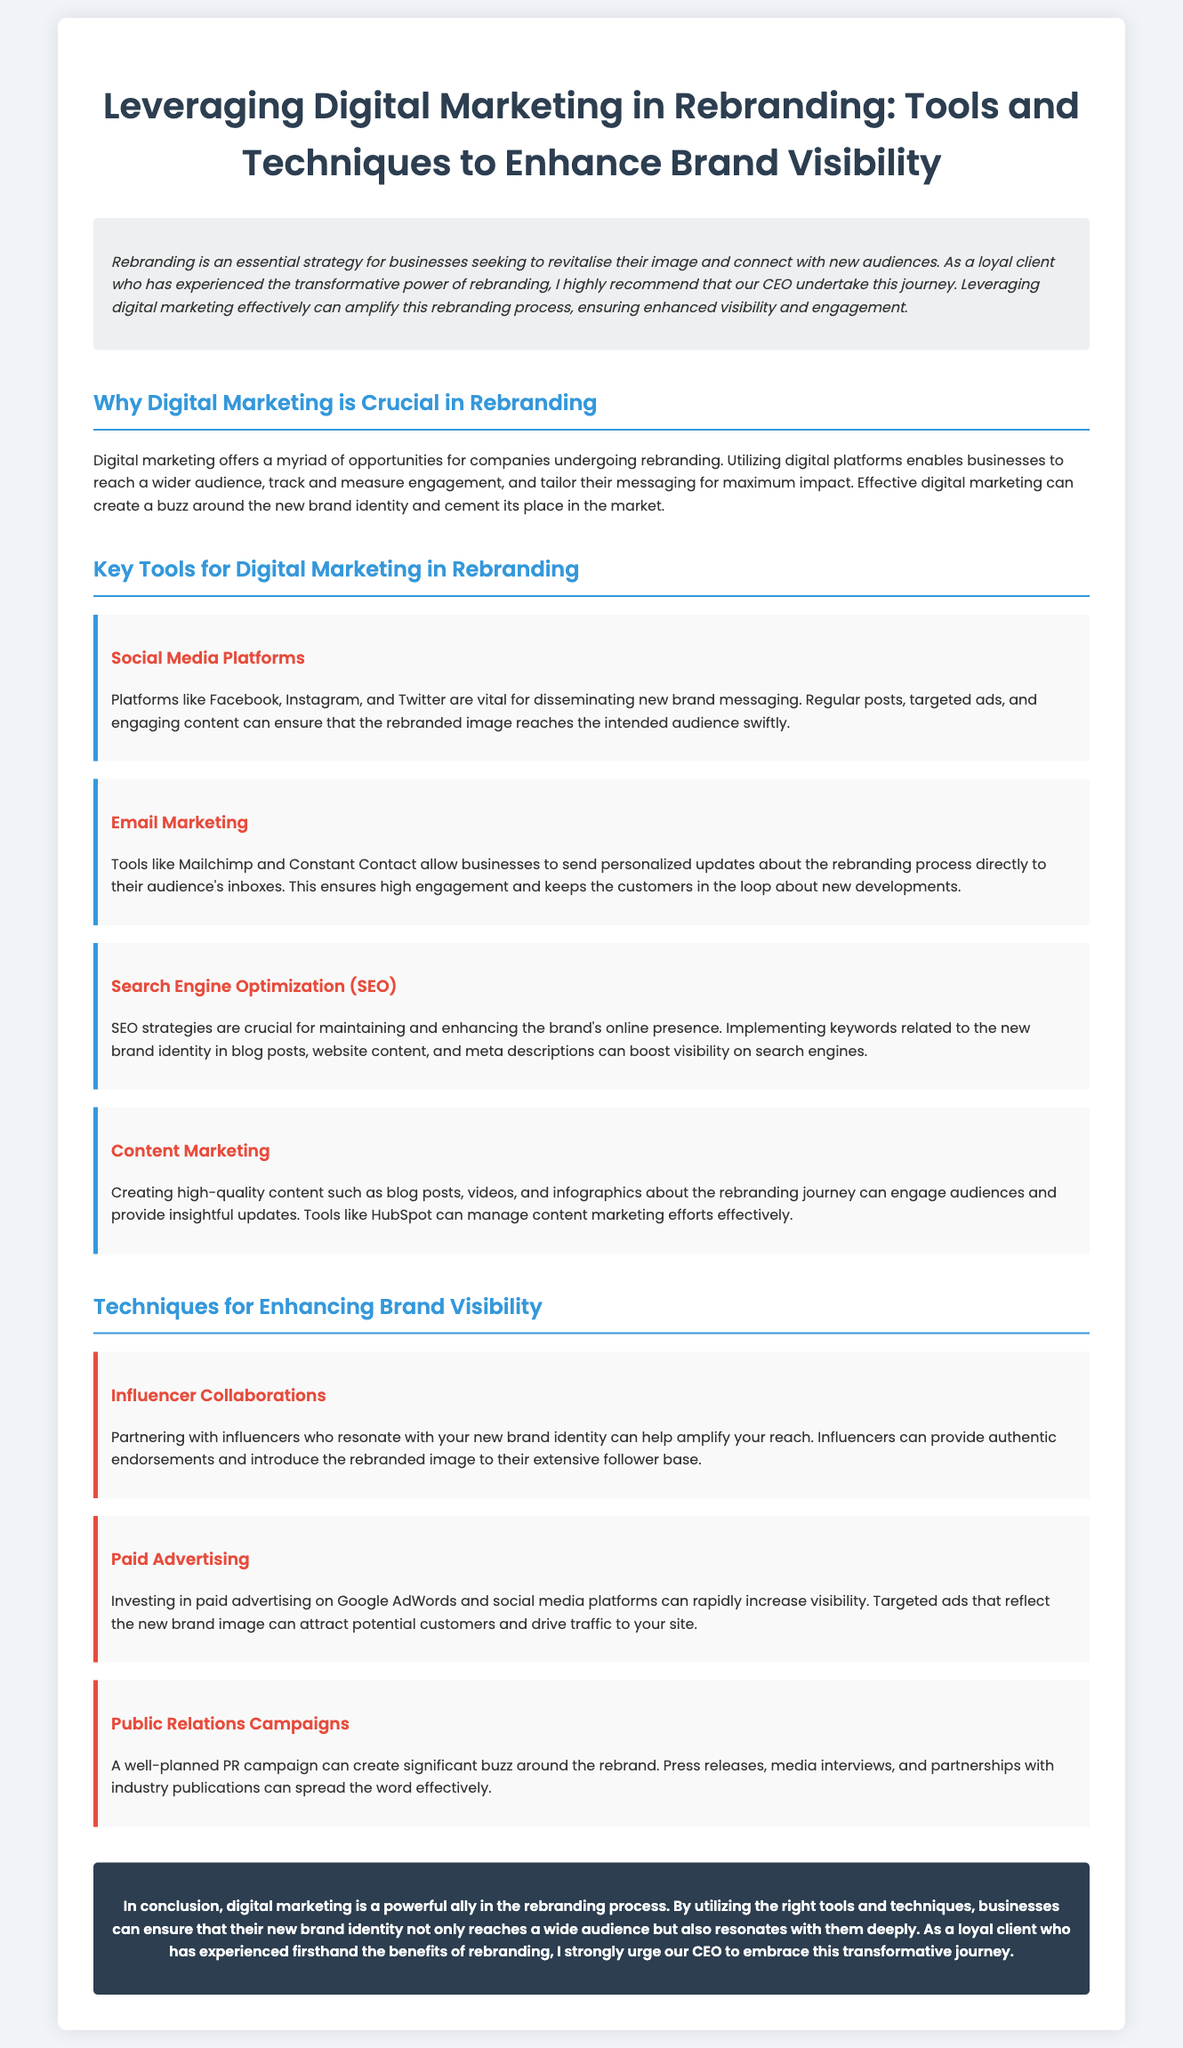What is the title of the document? The title of the document is indicated prominently at the top of the page.
Answer: Leveraging Digital Marketing in Rebranding: Tools and Techniques to Enhance Brand Visibility What are two key tools mentioned for digital marketing in rebranding? The document lists several tools; two are highlighted in dedicated sections.
Answer: Social Media Platforms, Email Marketing What is the color of the section headers? The document describes the color used for section headers in the style details.
Answer: #3498db Which SEO strategy is mentioned in the user guide? The user guide describes an SEO strategy related to brand identity.
Answer: Implementing keywords Name one technique for enhancing brand visibility. The document specifies various techniques, one of which is elaborated upon.
Answer: Influencer Collaborations How many main sections are there in this user guide? The document outline reveals the number of main sections present.
Answer: Five What is emphasized as crucial in the rebranding process? The introduction highlights the importance of a specific aspect related to rebranding.
Answer: Digital marketing What should brand messaging include according to the user guide? The document indicates what content should be communicated during rebranding.
Answer: New brand identity 